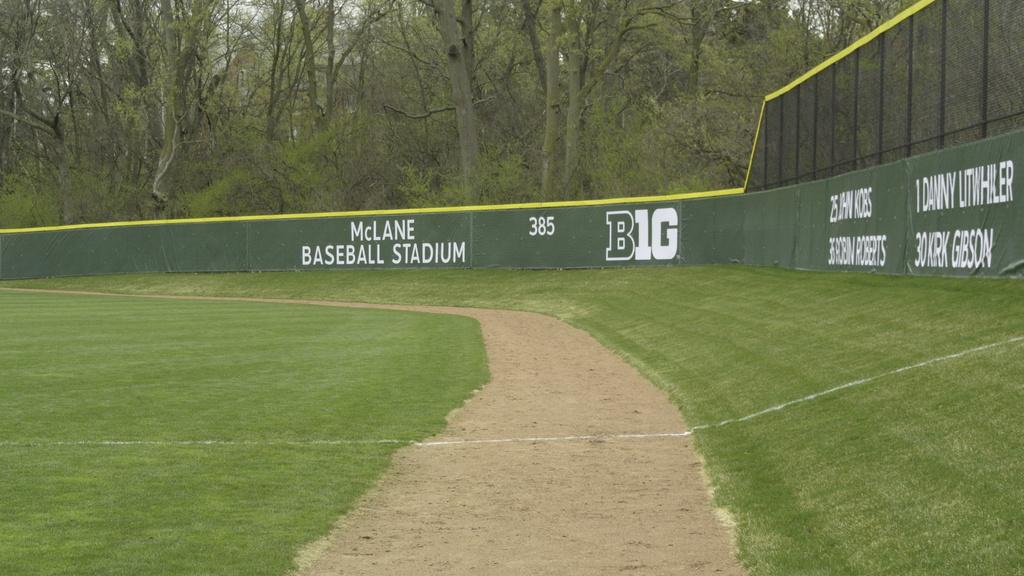What type of vegetation can be seen in the image? There is grass in the image. What type of man-made structure is present in the image? There is a road and a fence in the image. What is written on the fence? Something is written on the fence. What can be seen in the background of the image? There are trees in the background of the image. What type of quiver can be seen hanging from the trees in the image? There is no quiver present in the image; it features grass, a road, a fence, and trees. How many crows are perched on the fence in the image? There are no crows present in the image. 